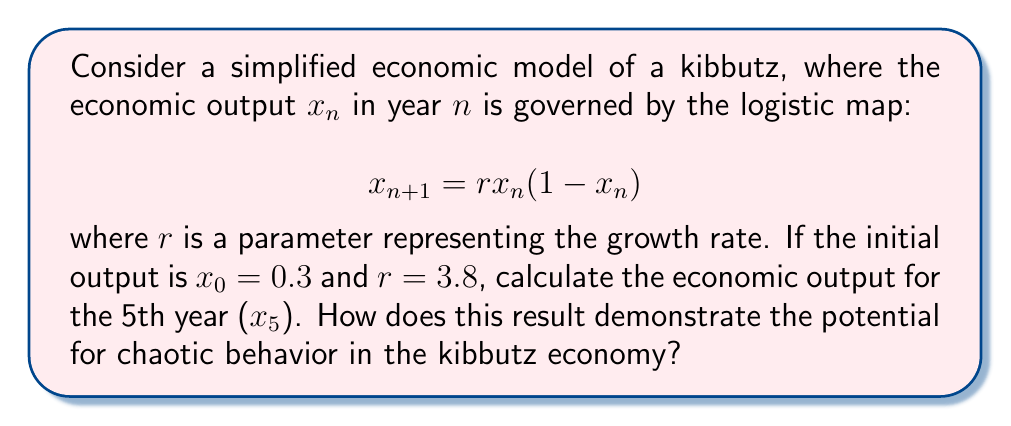Give your solution to this math problem. Let's approach this step-by-step:

1) We're given the logistic map: $x_{n+1} = rx_n(1-x_n)$
   With $r = 3.8$ and $x_0 = 0.3$

2) Let's calculate the values for each year:

   For $n = 0$:
   $x_1 = 3.8 * 0.3 * (1-0.3) = 3.8 * 0.3 * 0.7 = 0.798$

   For $n = 1$:
   $x_2 = 3.8 * 0.798 * (1-0.798) = 3.8 * 0.798 * 0.202 = 0.612696$

   For $n = 2$:
   $x_3 = 3.8 * 0.612696 * (1-0.612696) = 0.899799$

   For $n = 3$:
   $x_4 = 3.8 * 0.899799 * (1-0.899799) = 0.342523$

   For $n = 4$:
   $x_5 = 3.8 * 0.342523 * (1-0.342523) = 0.855513$

3) Therefore, the economic output for the 5th year is approximately 0.855513.

4) This result demonstrates the potential for chaotic behavior because:
   a) The output values do not converge to a single value or a simple periodic pattern.
   b) Small changes in the initial conditions or parameters can lead to drastically different outcomes.
   c) Despite the deterministic nature of the equation, long-term prediction is difficult due to the sensitivity to initial conditions.

This unpredictability aligns with the complex nature of real-world economies, especially in a communal setting like a kibbutz where many factors can influence economic output.
Answer: $x_5 \approx 0.855513$; demonstrates chaos through non-convergence and sensitivity to initial conditions. 